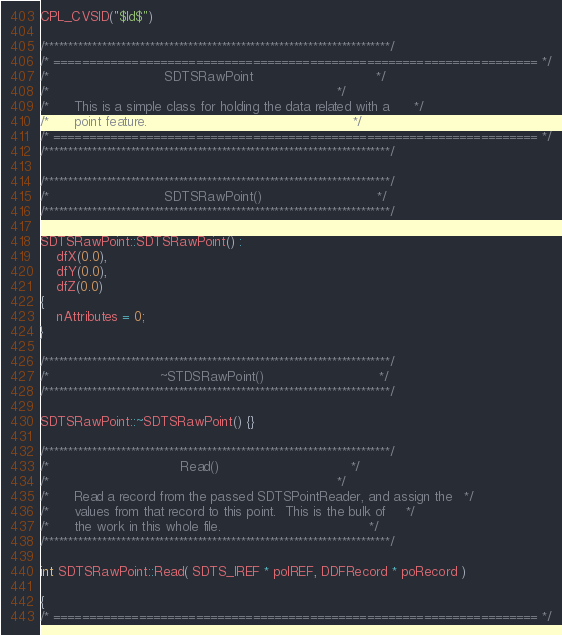Convert code to text. <code><loc_0><loc_0><loc_500><loc_500><_C++_>CPL_CVSID("$Id$")

/************************************************************************/
/* ==================================================================== */
/*                            SDTSRawPoint                              */
/*                                                                      */
/*      This is a simple class for holding the data related with a      */
/*      point feature.                                                  */
/* ==================================================================== */
/************************************************************************/

/************************************************************************/
/*                            SDTSRawPoint()                            */
/************************************************************************/

SDTSRawPoint::SDTSRawPoint() :
    dfX(0.0),
    dfY(0.0),
    dfZ(0.0)
{
    nAttributes = 0;
}

/************************************************************************/
/*                           ~STDSRawPoint()                            */
/************************************************************************/

SDTSRawPoint::~SDTSRawPoint() {}

/************************************************************************/
/*                                Read()                                */
/*                                                                      */
/*      Read a record from the passed SDTSPointReader, and assign the   */
/*      values from that record to this point.  This is the bulk of     */
/*      the work in this whole file.                                    */
/************************************************************************/

int SDTSRawPoint::Read( SDTS_IREF * poIREF, DDFRecord * poRecord )

{
/* ==================================================================== */</code> 